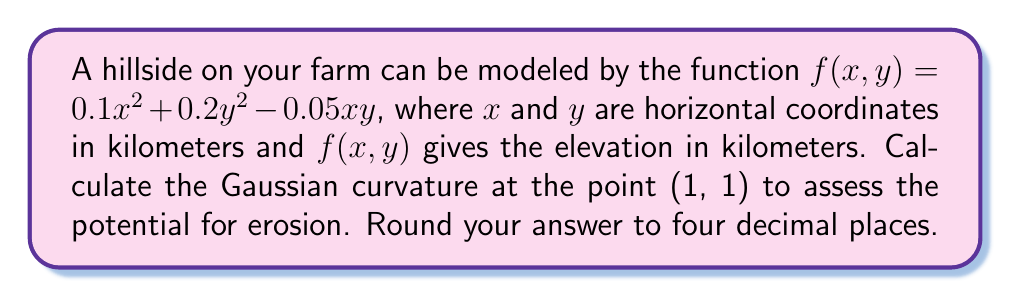What is the answer to this math problem? To calculate the Gaussian curvature, we need to follow these steps:

1) The Gaussian curvature $K$ is given by:

   $$K = \frac{f_{xx}f_{yy} - f_{xy}^2}{(1 + f_x^2 + f_y^2)^2}$$

   where subscripts denote partial derivatives.

2) Calculate the partial derivatives:
   
   $f_x = 0.2x - 0.05y$
   $f_y = 0.4y - 0.05x$
   $f_{xx} = 0.2$
   $f_{yy} = 0.4$
   $f_{xy} = -0.05$

3) Evaluate these at the point (1, 1):

   $f_x(1,1) = 0.2 - 0.05 = 0.15$
   $f_y(1,1) = 0.4 - 0.05 = 0.35$
   $f_{xx}(1,1) = 0.2$
   $f_{yy}(1,1) = 0.4$
   $f_{xy}(1,1) = -0.05$

4) Calculate the numerator:

   $f_{xx}f_{yy} - f_{xy}^2 = 0.2 \cdot 0.4 - (-0.05)^2 = 0.08 - 0.0025 = 0.0775$

5) Calculate the denominator:

   $(1 + f_x^2 + f_y^2)^2 = (1 + 0.15^2 + 0.35^2)^2 = (1.1450)^2 = 1.3110$

6) Divide the numerator by the denominator:

   $K = \frac{0.0775}{1.3110} = 0.0591$

7) Round to four decimal places:

   $K \approx 0.0591$
Answer: The Gaussian curvature at the point (1, 1) is approximately 0.0591. 